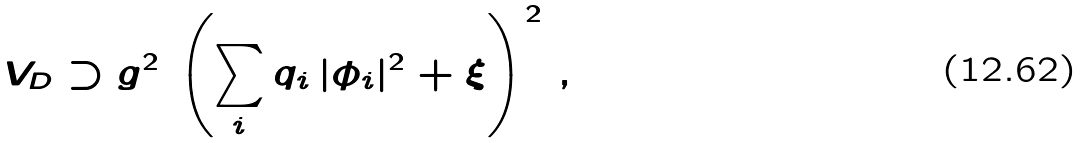Convert formula to latex. <formula><loc_0><loc_0><loc_500><loc_500>V _ { D } \supset g ^ { 2 } \, \left ( \sum _ { i } q _ { i } \, | \phi _ { i } | ^ { 2 } + \xi \right ) ^ { 2 } \, ,</formula> 